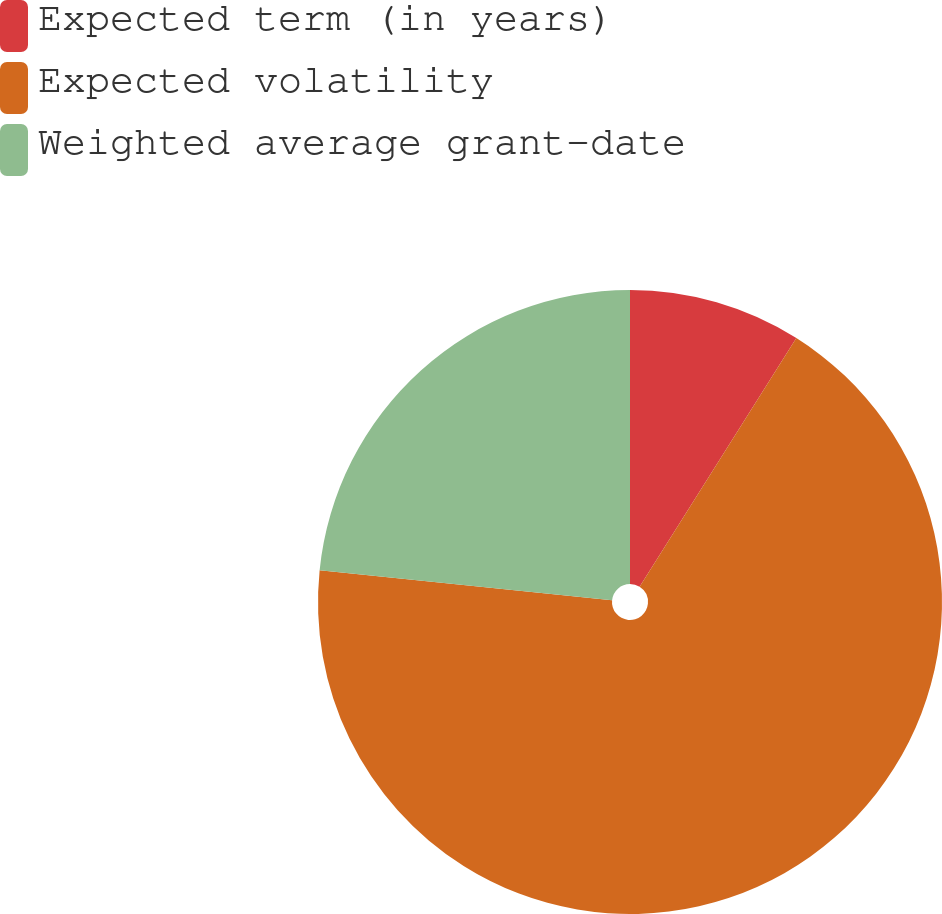Convert chart. <chart><loc_0><loc_0><loc_500><loc_500><pie_chart><fcel>Expected term (in years)<fcel>Expected volatility<fcel>Weighted average grant-date<nl><fcel>8.95%<fcel>67.67%<fcel>23.37%<nl></chart> 